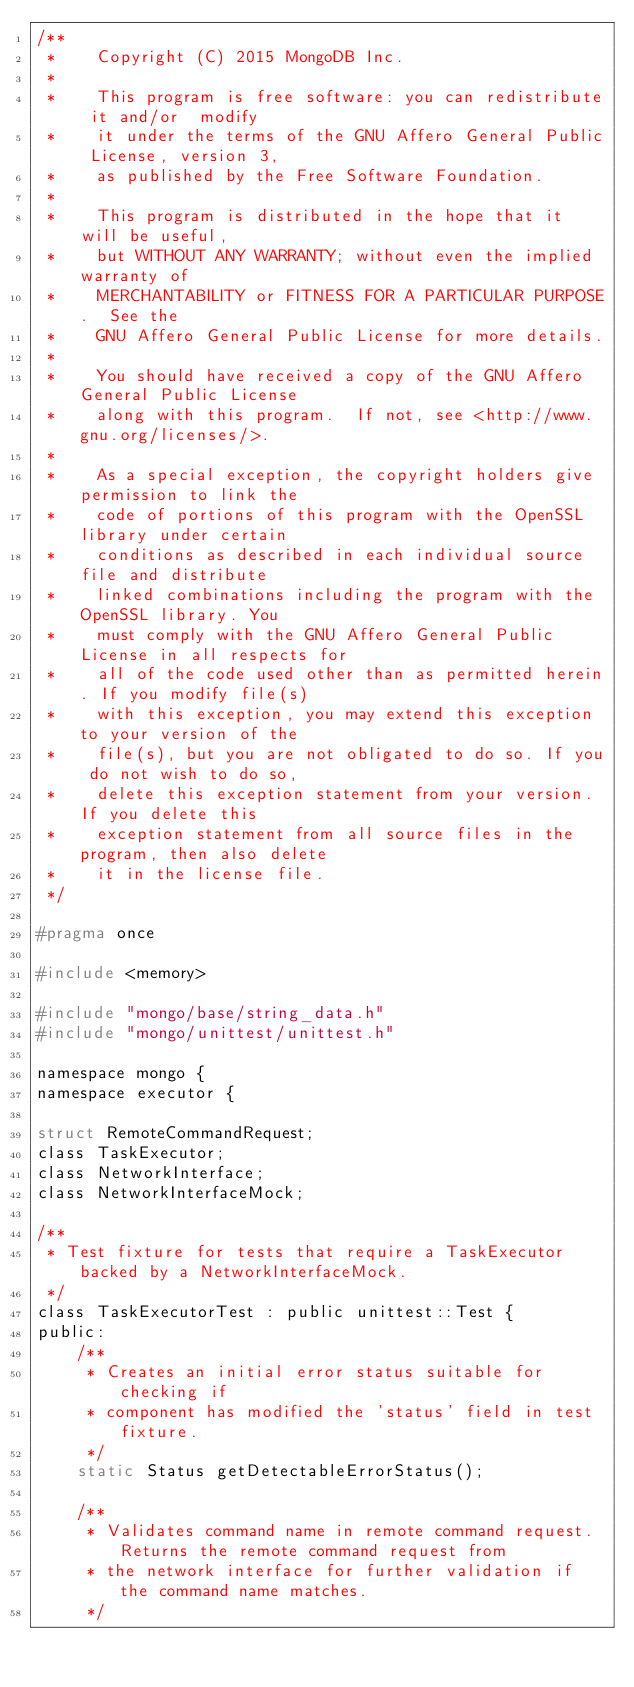<code> <loc_0><loc_0><loc_500><loc_500><_C_>/**
 *    Copyright (C) 2015 MongoDB Inc.
 *
 *    This program is free software: you can redistribute it and/or  modify
 *    it under the terms of the GNU Affero General Public License, version 3,
 *    as published by the Free Software Foundation.
 *
 *    This program is distributed in the hope that it will be useful,
 *    but WITHOUT ANY WARRANTY; without even the implied warranty of
 *    MERCHANTABILITY or FITNESS FOR A PARTICULAR PURPOSE.  See the
 *    GNU Affero General Public License for more details.
 *
 *    You should have received a copy of the GNU Affero General Public License
 *    along with this program.  If not, see <http://www.gnu.org/licenses/>.
 *
 *    As a special exception, the copyright holders give permission to link the
 *    code of portions of this program with the OpenSSL library under certain
 *    conditions as described in each individual source file and distribute
 *    linked combinations including the program with the OpenSSL library. You
 *    must comply with the GNU Affero General Public License in all respects for
 *    all of the code used other than as permitted herein. If you modify file(s)
 *    with this exception, you may extend this exception to your version of the
 *    file(s), but you are not obligated to do so. If you do not wish to do so,
 *    delete this exception statement from your version. If you delete this
 *    exception statement from all source files in the program, then also delete
 *    it in the license file.
 */

#pragma once

#include <memory>

#include "mongo/base/string_data.h"
#include "mongo/unittest/unittest.h"

namespace mongo {
namespace executor {

struct RemoteCommandRequest;
class TaskExecutor;
class NetworkInterface;
class NetworkInterfaceMock;

/**
 * Test fixture for tests that require a TaskExecutor backed by a NetworkInterfaceMock.
 */
class TaskExecutorTest : public unittest::Test {
public:
    /**
     * Creates an initial error status suitable for checking if
     * component has modified the 'status' field in test fixture.
     */
    static Status getDetectableErrorStatus();

    /**
     * Validates command name in remote command request. Returns the remote command request from
     * the network interface for further validation if the command name matches.
     */</code> 